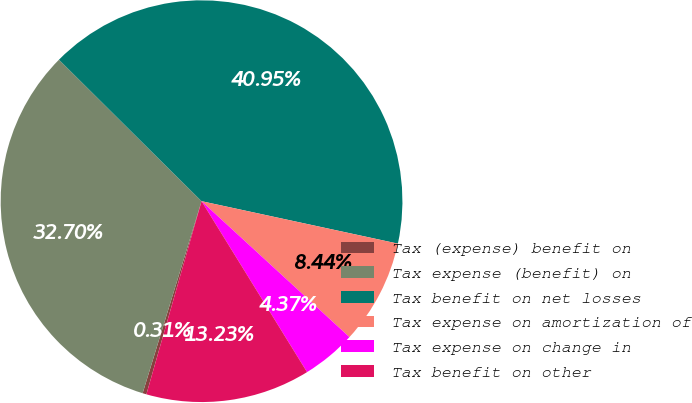<chart> <loc_0><loc_0><loc_500><loc_500><pie_chart><fcel>Tax (expense) benefit on<fcel>Tax expense (benefit) on<fcel>Tax benefit on net losses<fcel>Tax expense on amortization of<fcel>Tax expense on change in<fcel>Tax benefit on other<nl><fcel>0.31%<fcel>32.7%<fcel>40.95%<fcel>8.44%<fcel>4.37%<fcel>13.23%<nl></chart> 